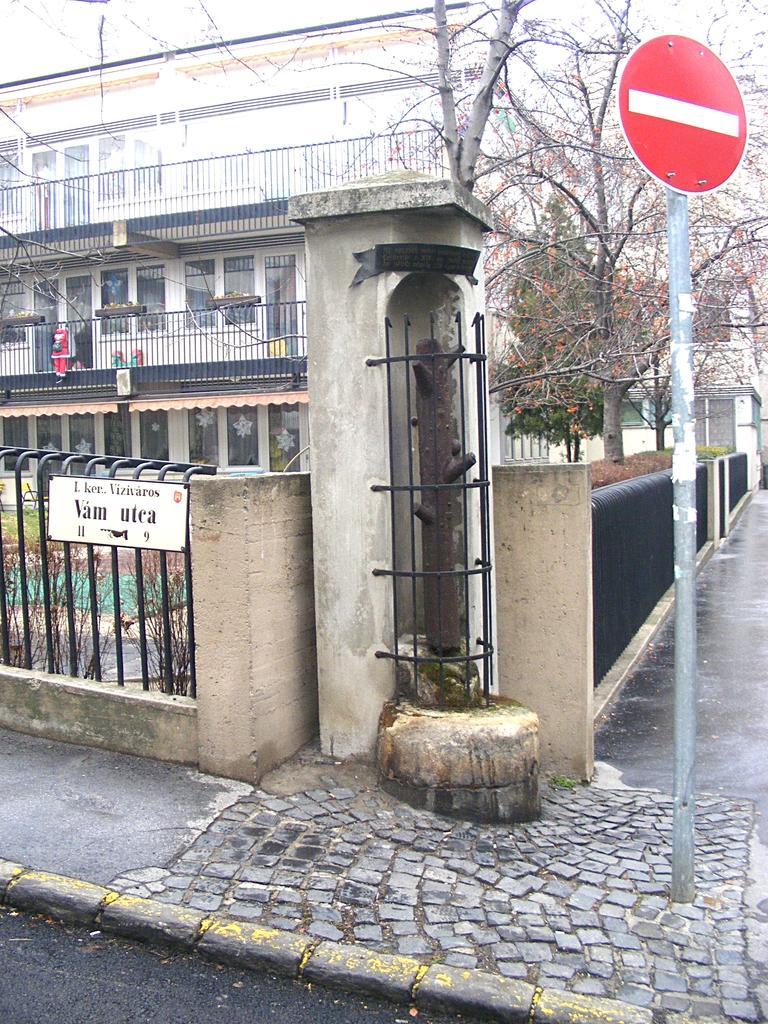Please provide a concise description of this image. In the picture I can see a red color board which is attached to the pole in the right corner and there is an object beside it and there is a fence on either sides of it and there is a building and few trees in the background. 